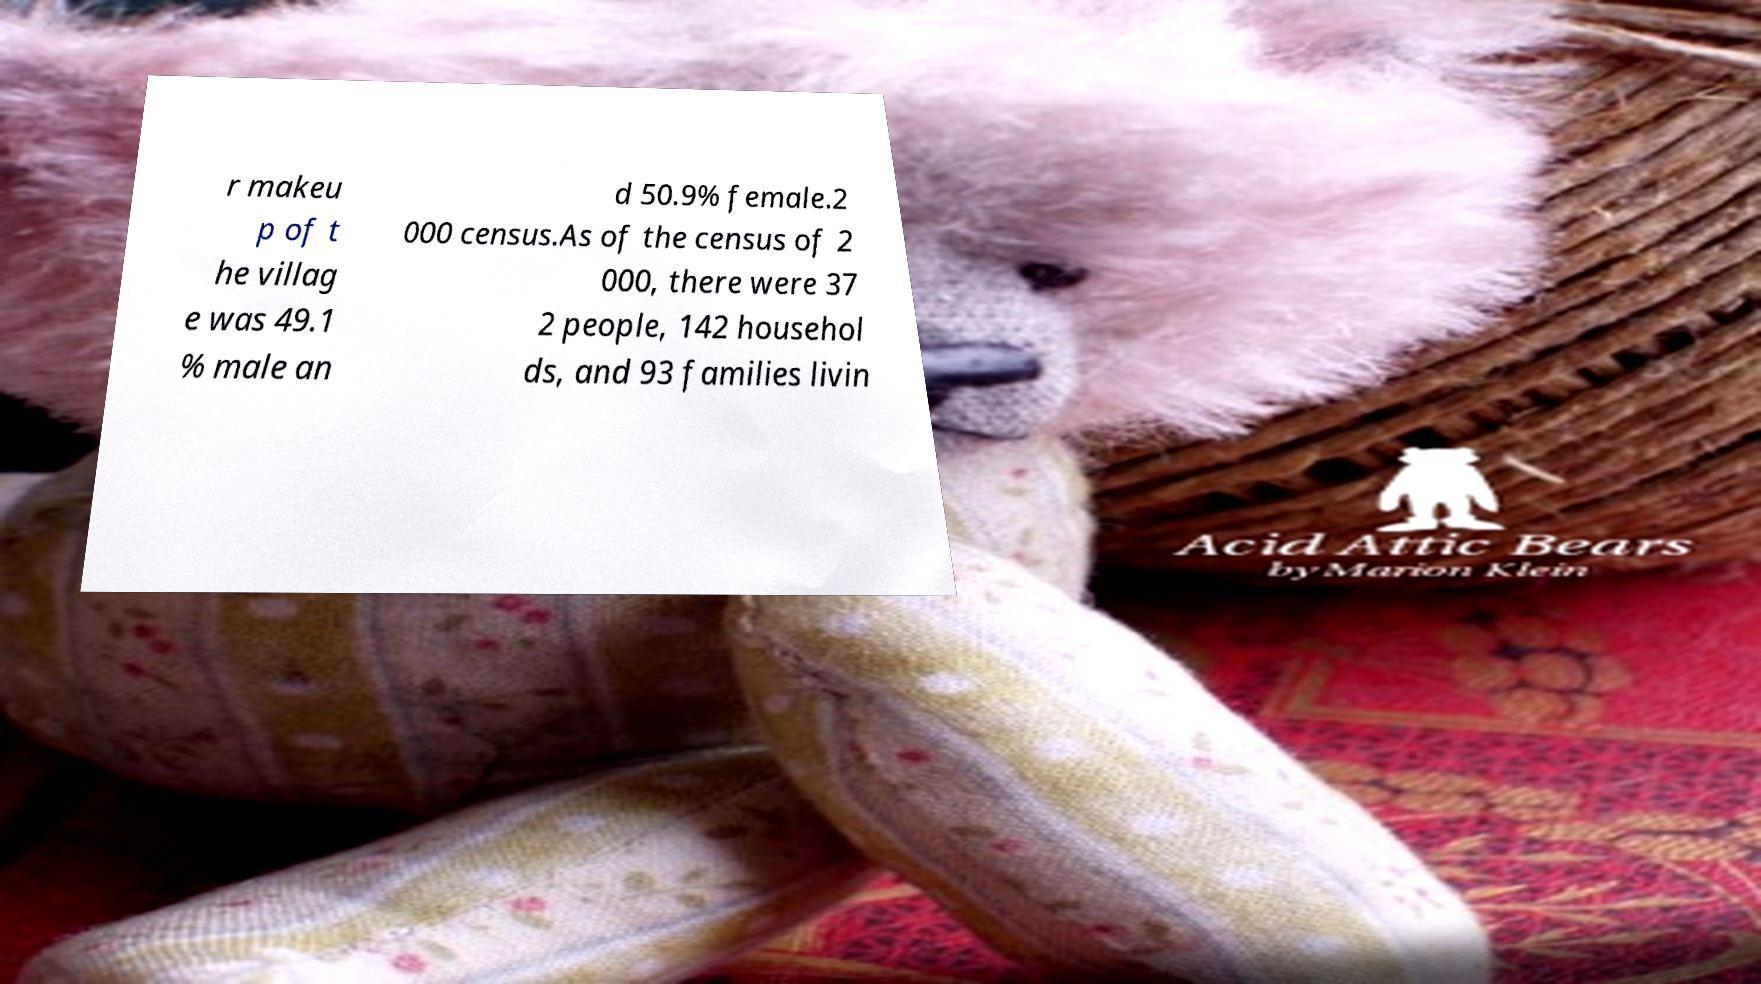Please read and relay the text visible in this image. What does it say? r makeu p of t he villag e was 49.1 % male an d 50.9% female.2 000 census.As of the census of 2 000, there were 37 2 people, 142 househol ds, and 93 families livin 